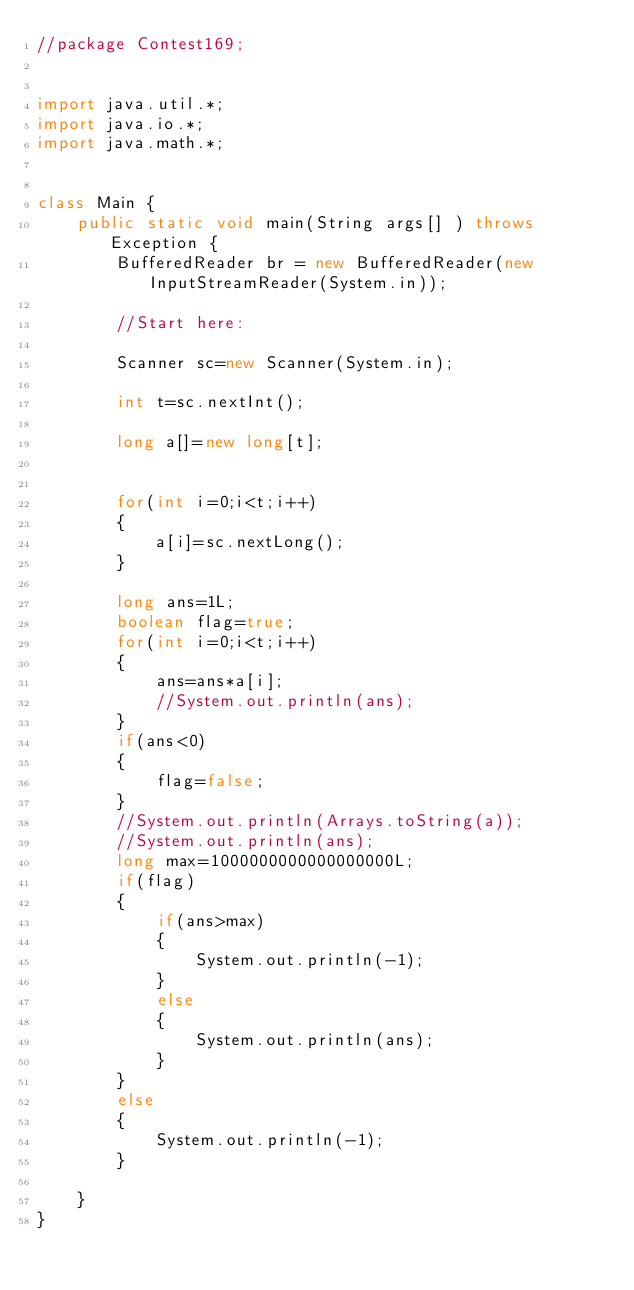<code> <loc_0><loc_0><loc_500><loc_500><_Java_>//package Contest169;


import java.util.*;
import java.io.*;
import java.math.*;


class Main {
    public static void main(String args[] ) throws Exception {
        BufferedReader br = new BufferedReader(new InputStreamReader(System.in));
        
        //Start here:
        
        Scanner sc=new Scanner(System.in);
        
        int t=sc.nextInt();
        
        long a[]=new long[t];
        
        
        for(int i=0;i<t;i++)
        {
        	a[i]=sc.nextLong();
        }
        
        long ans=1L;
        boolean flag=true;
        for(int i=0;i<t;i++)
        {
        	ans=ans*a[i];
        	//System.out.println(ans);
        }
        if(ans<0)
    	{
    		flag=false;
    	}
        //System.out.println(Arrays.toString(a));
        //System.out.println(ans);
        long max=1000000000000000000L;
        if(flag)
        {
        	if(ans>max)
        	{
        		System.out.println(-1);
        	}
        	else
        	{
        		System.out.println(ans);
        	}
        }
        else
        {
        	System.out.println(-1);
        }

    }
}</code> 